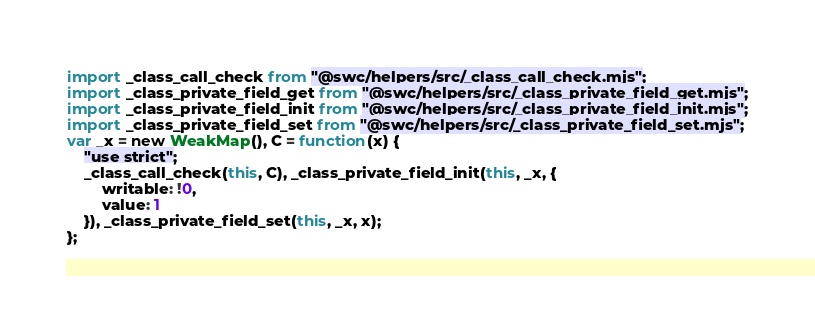<code> <loc_0><loc_0><loc_500><loc_500><_JavaScript_>import _class_call_check from "@swc/helpers/src/_class_call_check.mjs";
import _class_private_field_get from "@swc/helpers/src/_class_private_field_get.mjs";
import _class_private_field_init from "@swc/helpers/src/_class_private_field_init.mjs";
import _class_private_field_set from "@swc/helpers/src/_class_private_field_set.mjs";
var _x = new WeakMap(), C = function(x) {
    "use strict";
    _class_call_check(this, C), _class_private_field_init(this, _x, {
        writable: !0,
        value: 1
    }), _class_private_field_set(this, _x, x);
};
</code> 